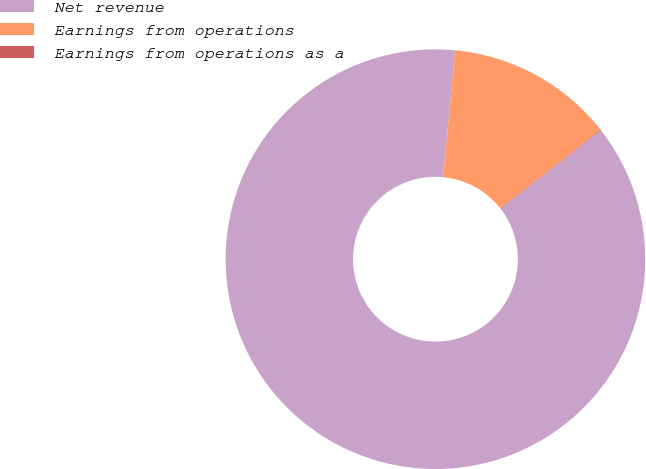Convert chart to OTSL. <chart><loc_0><loc_0><loc_500><loc_500><pie_chart><fcel>Net revenue<fcel>Earnings from operations<fcel>Earnings from operations as a<nl><fcel>87.03%<fcel>12.92%<fcel>0.05%<nl></chart> 